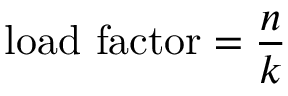Convert formula to latex. <formula><loc_0><loc_0><loc_500><loc_500>{ l o a d f a c t o r } = { \frac { n } { k } }</formula> 